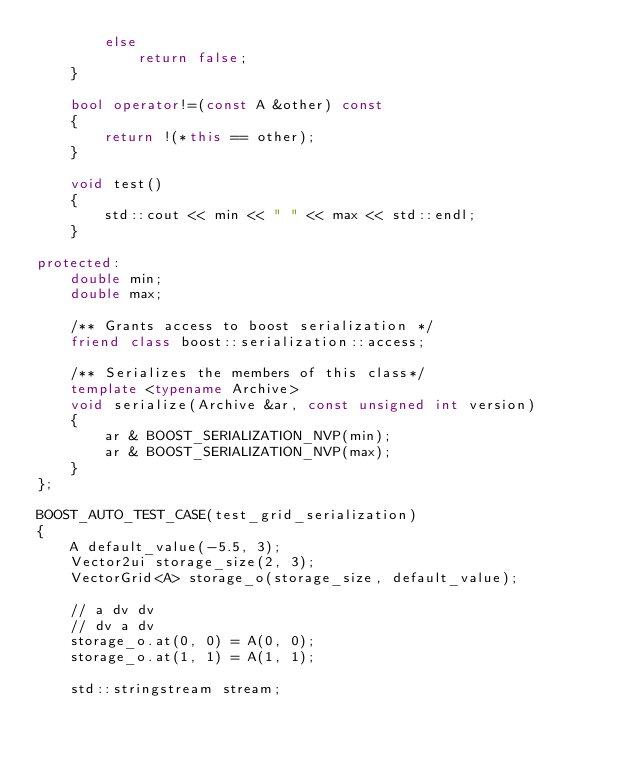Convert code to text. <code><loc_0><loc_0><loc_500><loc_500><_C++_>        else
            return false;
    }

    bool operator!=(const A &other) const
    {
        return !(*this == other);
    }

    void test()
    {
        std::cout << min << " " << max << std::endl;
    }

protected:
    double min;
    double max;

    /** Grants access to boost serialization */
    friend class boost::serialization::access;  

    /** Serializes the members of this class*/
    template <typename Archive>
    void serialize(Archive &ar, const unsigned int version)
    {
        ar & BOOST_SERIALIZATION_NVP(min);
        ar & BOOST_SERIALIZATION_NVP(max);
    }
};

BOOST_AUTO_TEST_CASE(test_grid_serialization)
{
    A default_value(-5.5, 3);
    Vector2ui storage_size(2, 3);
    VectorGrid<A> storage_o(storage_size, default_value);

    // a dv dv
    // dv a dv
    storage_o.at(0, 0) = A(0, 0);
    storage_o.at(1, 1) = A(1, 1);

    std::stringstream stream;</code> 